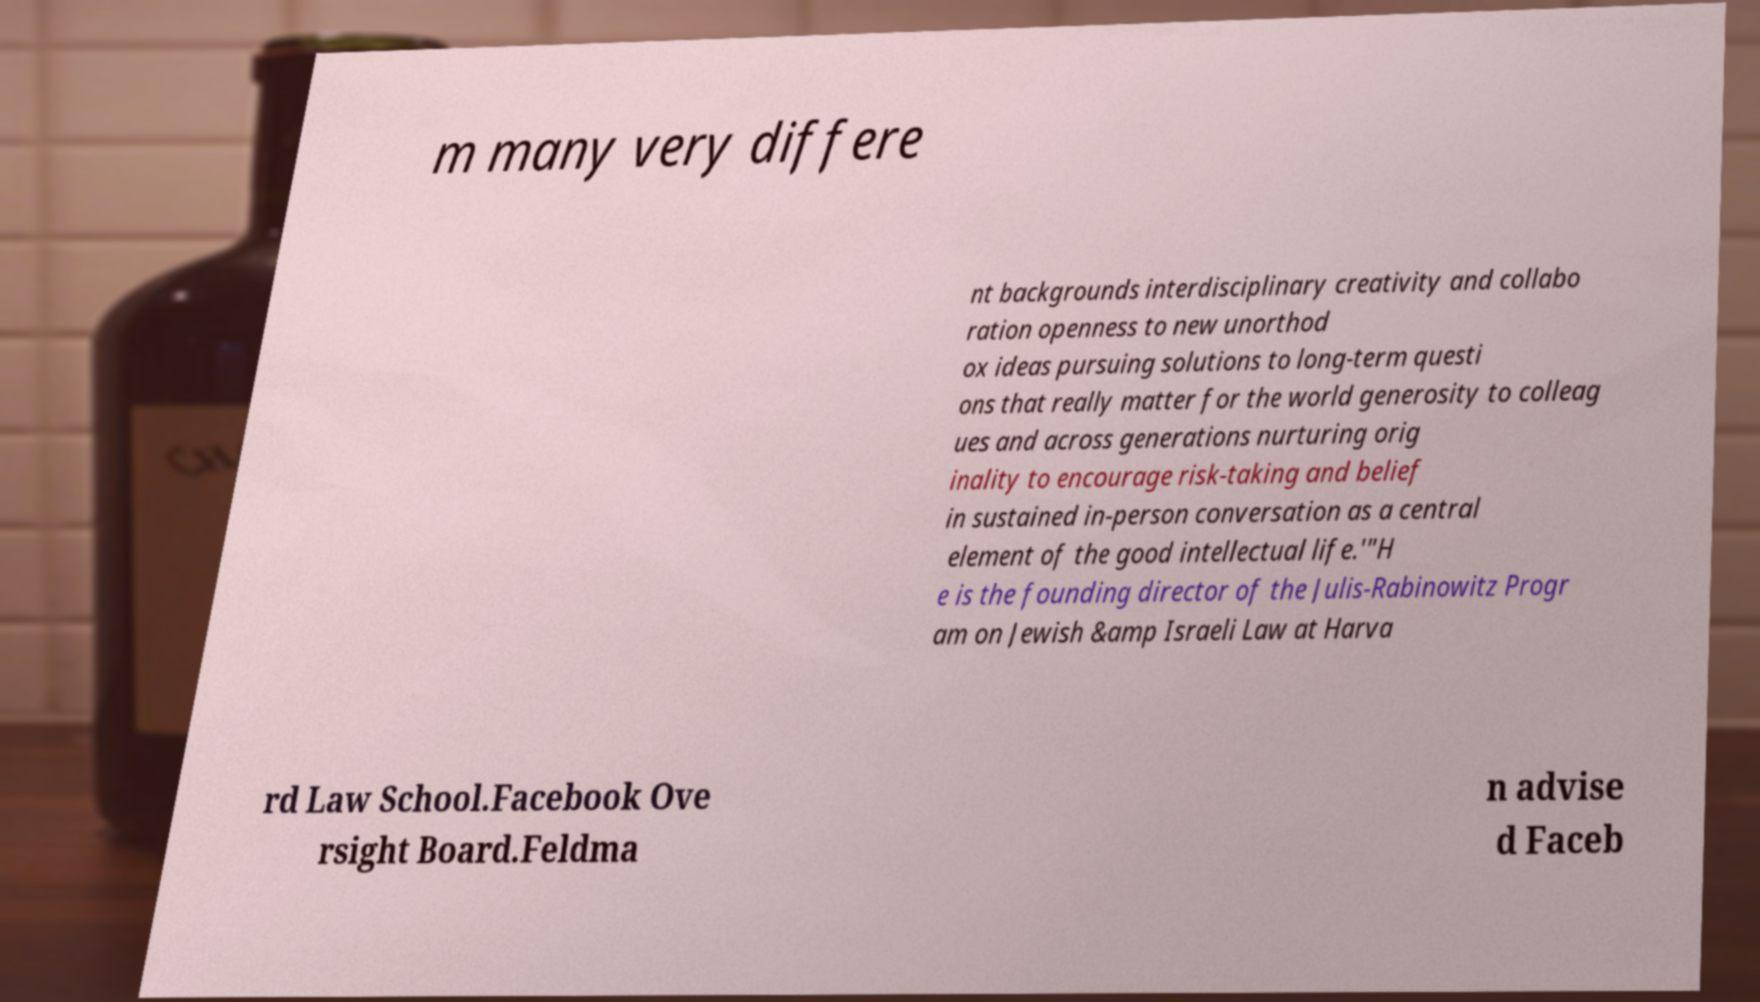For documentation purposes, I need the text within this image transcribed. Could you provide that? m many very differe nt backgrounds interdisciplinary creativity and collabo ration openness to new unorthod ox ideas pursuing solutions to long-term questi ons that really matter for the world generosity to colleag ues and across generations nurturing orig inality to encourage risk-taking and belief in sustained in-person conversation as a central element of the good intellectual life.'"H e is the founding director of the Julis-Rabinowitz Progr am on Jewish &amp Israeli Law at Harva rd Law School.Facebook Ove rsight Board.Feldma n advise d Faceb 